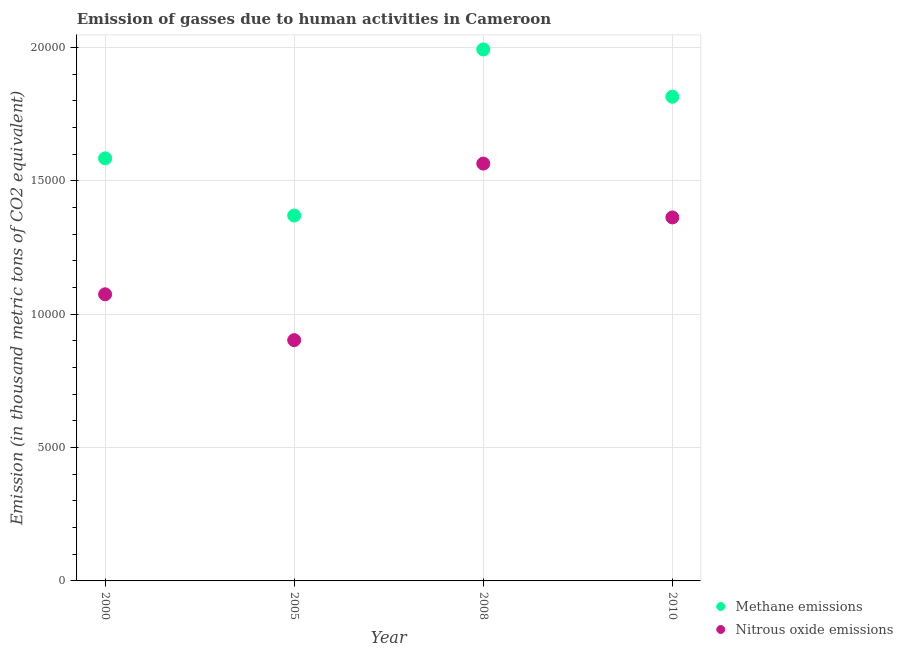What is the amount of methane emissions in 2005?
Keep it short and to the point. 1.37e+04. Across all years, what is the maximum amount of methane emissions?
Ensure brevity in your answer.  1.99e+04. Across all years, what is the minimum amount of methane emissions?
Make the answer very short. 1.37e+04. What is the total amount of nitrous oxide emissions in the graph?
Your answer should be compact. 4.90e+04. What is the difference between the amount of methane emissions in 2008 and that in 2010?
Provide a succinct answer. 1774.1. What is the difference between the amount of methane emissions in 2000 and the amount of nitrous oxide emissions in 2005?
Offer a very short reply. 6815.7. What is the average amount of nitrous oxide emissions per year?
Keep it short and to the point. 1.23e+04. In the year 2000, what is the difference between the amount of methane emissions and amount of nitrous oxide emissions?
Your answer should be very brief. 5097.1. What is the ratio of the amount of methane emissions in 2008 to that in 2010?
Offer a very short reply. 1.1. What is the difference between the highest and the second highest amount of methane emissions?
Offer a terse response. 1774.1. What is the difference between the highest and the lowest amount of nitrous oxide emissions?
Your response must be concise. 6619.5. In how many years, is the amount of nitrous oxide emissions greater than the average amount of nitrous oxide emissions taken over all years?
Ensure brevity in your answer.  2. Does the amount of nitrous oxide emissions monotonically increase over the years?
Keep it short and to the point. No. Is the amount of nitrous oxide emissions strictly greater than the amount of methane emissions over the years?
Keep it short and to the point. No. How many years are there in the graph?
Offer a terse response. 4. What is the difference between two consecutive major ticks on the Y-axis?
Your answer should be very brief. 5000. Are the values on the major ticks of Y-axis written in scientific E-notation?
Keep it short and to the point. No. How many legend labels are there?
Make the answer very short. 2. How are the legend labels stacked?
Provide a succinct answer. Vertical. What is the title of the graph?
Keep it short and to the point. Emission of gasses due to human activities in Cameroon. Does "Lowest 10% of population" appear as one of the legend labels in the graph?
Keep it short and to the point. No. What is the label or title of the X-axis?
Your answer should be compact. Year. What is the label or title of the Y-axis?
Keep it short and to the point. Emission (in thousand metric tons of CO2 equivalent). What is the Emission (in thousand metric tons of CO2 equivalent) in Methane emissions in 2000?
Offer a terse response. 1.58e+04. What is the Emission (in thousand metric tons of CO2 equivalent) in Nitrous oxide emissions in 2000?
Your answer should be very brief. 1.07e+04. What is the Emission (in thousand metric tons of CO2 equivalent) of Methane emissions in 2005?
Provide a succinct answer. 1.37e+04. What is the Emission (in thousand metric tons of CO2 equivalent) of Nitrous oxide emissions in 2005?
Ensure brevity in your answer.  9027.2. What is the Emission (in thousand metric tons of CO2 equivalent) in Methane emissions in 2008?
Offer a very short reply. 1.99e+04. What is the Emission (in thousand metric tons of CO2 equivalent) in Nitrous oxide emissions in 2008?
Your answer should be very brief. 1.56e+04. What is the Emission (in thousand metric tons of CO2 equivalent) in Methane emissions in 2010?
Your answer should be compact. 1.82e+04. What is the Emission (in thousand metric tons of CO2 equivalent) in Nitrous oxide emissions in 2010?
Offer a very short reply. 1.36e+04. Across all years, what is the maximum Emission (in thousand metric tons of CO2 equivalent) in Methane emissions?
Make the answer very short. 1.99e+04. Across all years, what is the maximum Emission (in thousand metric tons of CO2 equivalent) in Nitrous oxide emissions?
Offer a very short reply. 1.56e+04. Across all years, what is the minimum Emission (in thousand metric tons of CO2 equivalent) of Methane emissions?
Offer a very short reply. 1.37e+04. Across all years, what is the minimum Emission (in thousand metric tons of CO2 equivalent) in Nitrous oxide emissions?
Ensure brevity in your answer.  9027.2. What is the total Emission (in thousand metric tons of CO2 equivalent) of Methane emissions in the graph?
Provide a succinct answer. 6.76e+04. What is the total Emission (in thousand metric tons of CO2 equivalent) in Nitrous oxide emissions in the graph?
Keep it short and to the point. 4.90e+04. What is the difference between the Emission (in thousand metric tons of CO2 equivalent) in Methane emissions in 2000 and that in 2005?
Give a very brief answer. 2143.3. What is the difference between the Emission (in thousand metric tons of CO2 equivalent) in Nitrous oxide emissions in 2000 and that in 2005?
Provide a succinct answer. 1718.6. What is the difference between the Emission (in thousand metric tons of CO2 equivalent) in Methane emissions in 2000 and that in 2008?
Provide a short and direct response. -4084.4. What is the difference between the Emission (in thousand metric tons of CO2 equivalent) of Nitrous oxide emissions in 2000 and that in 2008?
Provide a short and direct response. -4900.9. What is the difference between the Emission (in thousand metric tons of CO2 equivalent) in Methane emissions in 2000 and that in 2010?
Make the answer very short. -2310.3. What is the difference between the Emission (in thousand metric tons of CO2 equivalent) of Nitrous oxide emissions in 2000 and that in 2010?
Provide a short and direct response. -2881.9. What is the difference between the Emission (in thousand metric tons of CO2 equivalent) of Methane emissions in 2005 and that in 2008?
Your answer should be very brief. -6227.7. What is the difference between the Emission (in thousand metric tons of CO2 equivalent) in Nitrous oxide emissions in 2005 and that in 2008?
Your answer should be very brief. -6619.5. What is the difference between the Emission (in thousand metric tons of CO2 equivalent) in Methane emissions in 2005 and that in 2010?
Your answer should be very brief. -4453.6. What is the difference between the Emission (in thousand metric tons of CO2 equivalent) of Nitrous oxide emissions in 2005 and that in 2010?
Provide a succinct answer. -4600.5. What is the difference between the Emission (in thousand metric tons of CO2 equivalent) in Methane emissions in 2008 and that in 2010?
Ensure brevity in your answer.  1774.1. What is the difference between the Emission (in thousand metric tons of CO2 equivalent) in Nitrous oxide emissions in 2008 and that in 2010?
Your answer should be very brief. 2019. What is the difference between the Emission (in thousand metric tons of CO2 equivalent) in Methane emissions in 2000 and the Emission (in thousand metric tons of CO2 equivalent) in Nitrous oxide emissions in 2005?
Your answer should be very brief. 6815.7. What is the difference between the Emission (in thousand metric tons of CO2 equivalent) of Methane emissions in 2000 and the Emission (in thousand metric tons of CO2 equivalent) of Nitrous oxide emissions in 2008?
Ensure brevity in your answer.  196.2. What is the difference between the Emission (in thousand metric tons of CO2 equivalent) in Methane emissions in 2000 and the Emission (in thousand metric tons of CO2 equivalent) in Nitrous oxide emissions in 2010?
Give a very brief answer. 2215.2. What is the difference between the Emission (in thousand metric tons of CO2 equivalent) of Methane emissions in 2005 and the Emission (in thousand metric tons of CO2 equivalent) of Nitrous oxide emissions in 2008?
Provide a succinct answer. -1947.1. What is the difference between the Emission (in thousand metric tons of CO2 equivalent) of Methane emissions in 2005 and the Emission (in thousand metric tons of CO2 equivalent) of Nitrous oxide emissions in 2010?
Give a very brief answer. 71.9. What is the difference between the Emission (in thousand metric tons of CO2 equivalent) in Methane emissions in 2008 and the Emission (in thousand metric tons of CO2 equivalent) in Nitrous oxide emissions in 2010?
Give a very brief answer. 6299.6. What is the average Emission (in thousand metric tons of CO2 equivalent) in Methane emissions per year?
Make the answer very short. 1.69e+04. What is the average Emission (in thousand metric tons of CO2 equivalent) in Nitrous oxide emissions per year?
Ensure brevity in your answer.  1.23e+04. In the year 2000, what is the difference between the Emission (in thousand metric tons of CO2 equivalent) of Methane emissions and Emission (in thousand metric tons of CO2 equivalent) of Nitrous oxide emissions?
Give a very brief answer. 5097.1. In the year 2005, what is the difference between the Emission (in thousand metric tons of CO2 equivalent) of Methane emissions and Emission (in thousand metric tons of CO2 equivalent) of Nitrous oxide emissions?
Offer a terse response. 4672.4. In the year 2008, what is the difference between the Emission (in thousand metric tons of CO2 equivalent) of Methane emissions and Emission (in thousand metric tons of CO2 equivalent) of Nitrous oxide emissions?
Offer a very short reply. 4280.6. In the year 2010, what is the difference between the Emission (in thousand metric tons of CO2 equivalent) of Methane emissions and Emission (in thousand metric tons of CO2 equivalent) of Nitrous oxide emissions?
Ensure brevity in your answer.  4525.5. What is the ratio of the Emission (in thousand metric tons of CO2 equivalent) of Methane emissions in 2000 to that in 2005?
Provide a short and direct response. 1.16. What is the ratio of the Emission (in thousand metric tons of CO2 equivalent) in Nitrous oxide emissions in 2000 to that in 2005?
Provide a short and direct response. 1.19. What is the ratio of the Emission (in thousand metric tons of CO2 equivalent) in Methane emissions in 2000 to that in 2008?
Your answer should be very brief. 0.8. What is the ratio of the Emission (in thousand metric tons of CO2 equivalent) of Nitrous oxide emissions in 2000 to that in 2008?
Your answer should be compact. 0.69. What is the ratio of the Emission (in thousand metric tons of CO2 equivalent) in Methane emissions in 2000 to that in 2010?
Provide a succinct answer. 0.87. What is the ratio of the Emission (in thousand metric tons of CO2 equivalent) of Nitrous oxide emissions in 2000 to that in 2010?
Your response must be concise. 0.79. What is the ratio of the Emission (in thousand metric tons of CO2 equivalent) of Methane emissions in 2005 to that in 2008?
Provide a short and direct response. 0.69. What is the ratio of the Emission (in thousand metric tons of CO2 equivalent) in Nitrous oxide emissions in 2005 to that in 2008?
Your answer should be compact. 0.58. What is the ratio of the Emission (in thousand metric tons of CO2 equivalent) in Methane emissions in 2005 to that in 2010?
Your answer should be very brief. 0.75. What is the ratio of the Emission (in thousand metric tons of CO2 equivalent) in Nitrous oxide emissions in 2005 to that in 2010?
Your answer should be compact. 0.66. What is the ratio of the Emission (in thousand metric tons of CO2 equivalent) in Methane emissions in 2008 to that in 2010?
Your answer should be very brief. 1.1. What is the ratio of the Emission (in thousand metric tons of CO2 equivalent) in Nitrous oxide emissions in 2008 to that in 2010?
Give a very brief answer. 1.15. What is the difference between the highest and the second highest Emission (in thousand metric tons of CO2 equivalent) of Methane emissions?
Make the answer very short. 1774.1. What is the difference between the highest and the second highest Emission (in thousand metric tons of CO2 equivalent) in Nitrous oxide emissions?
Your answer should be compact. 2019. What is the difference between the highest and the lowest Emission (in thousand metric tons of CO2 equivalent) in Methane emissions?
Your response must be concise. 6227.7. What is the difference between the highest and the lowest Emission (in thousand metric tons of CO2 equivalent) in Nitrous oxide emissions?
Your answer should be compact. 6619.5. 